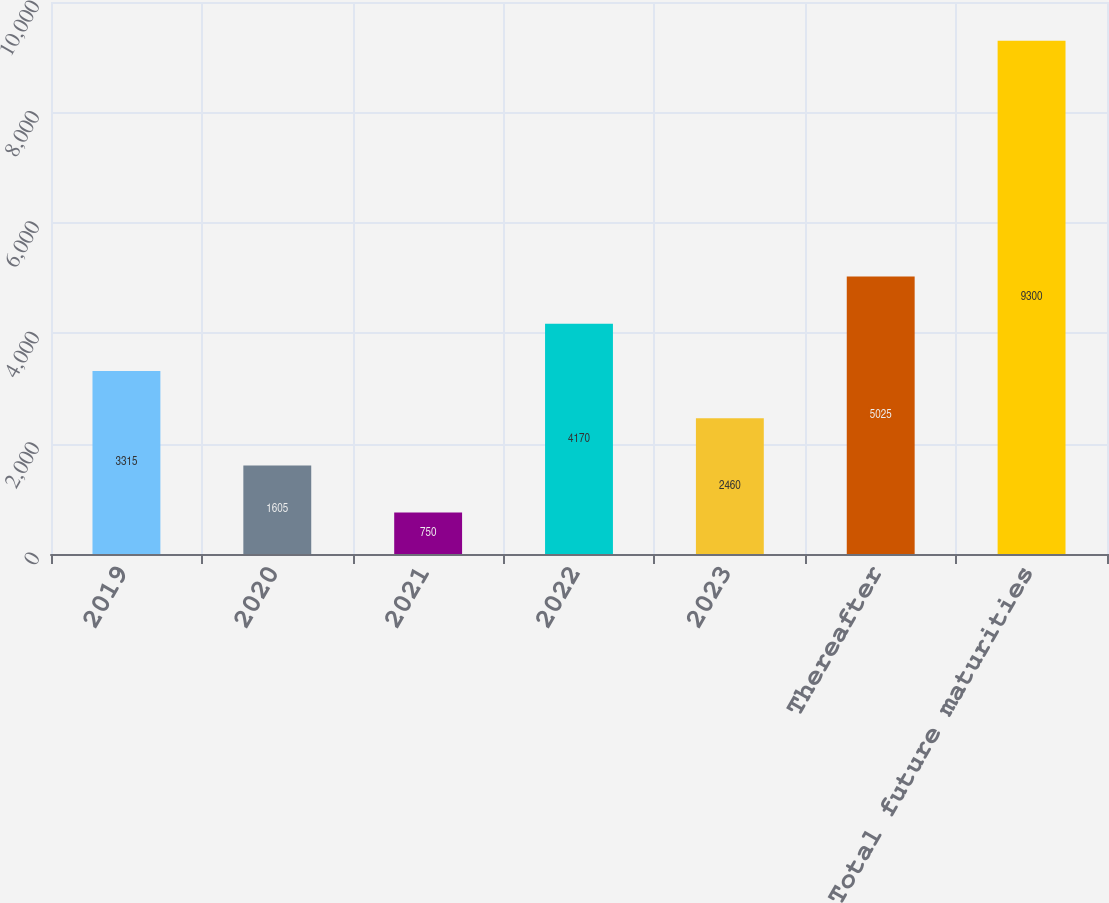Convert chart. <chart><loc_0><loc_0><loc_500><loc_500><bar_chart><fcel>2019<fcel>2020<fcel>2021<fcel>2022<fcel>2023<fcel>Thereafter<fcel>Total future maturities<nl><fcel>3315<fcel>1605<fcel>750<fcel>4170<fcel>2460<fcel>5025<fcel>9300<nl></chart> 